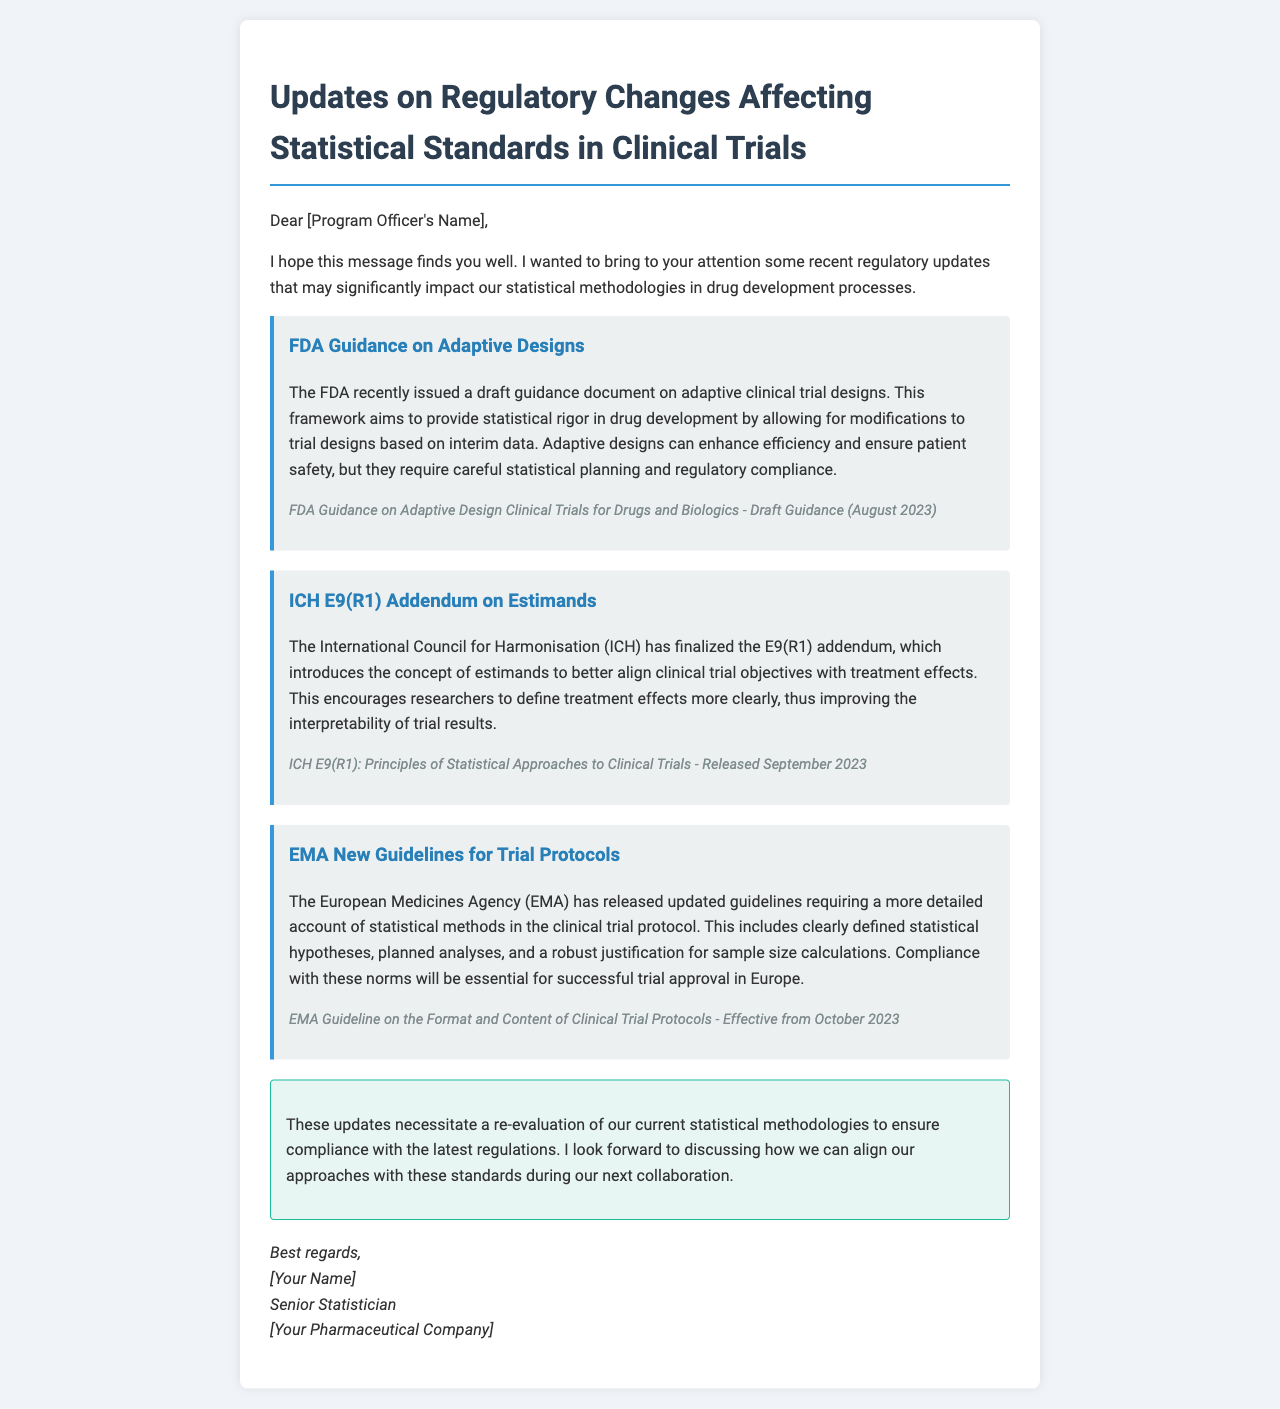What is the title of the document? The title is mentioned at the top of the document, indicating the subject matter related to regulatory updates.
Answer: Updates on Regulatory Changes Affecting Statistical Standards in Clinical Trials Who issued the draft guidance on adaptive clinical trial designs? The document specifies the issuing authority of the draft guidance.
Answer: FDA What concept does the ICH E9(R1) addendum introduce? The document highlights a key concept introduced in the ICH E9(R1) addendum related to clinical trials.
Answer: Estimands When is the EMA guideline effective from? The effective date for the EMA guideline is noted in the document.
Answer: October 2023 What does the EMA require in trial protocols? The document discusses specific requirements set by the EMA for trial protocols.
Answer: Detailed account of statistical methods What is the purpose of adaptive trial designs? The document provides a rationale for implementing adaptive designs in clinical trials.
Answer: Enhance efficiency and ensure patient safety Who is the sender of the document? The document contains the signature of the individual sending the email.
Answer: Senior Statistician What is a key action recommended in the conclusion? The conclusion of the document suggests an important next step following the updates.
Answer: Re-evaluation of current statistical methodologies 